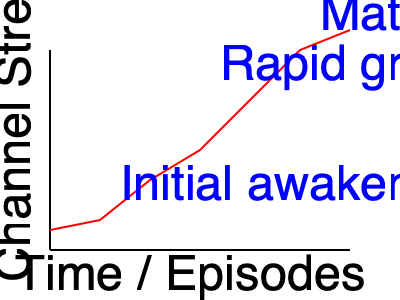Analyze the graph representing Naota's N.O. channel strength throughout FLCL. How does this visualization symbolize Naota's coming-of-age journey, and what specific events in the series might correspond to the marked points of change? 1. Initial state: The graph begins with a relatively flat line, representing Naota's dormant N.O. channel at the start of the series.

2. Awakening: The first significant change occurs early in the series, likely corresponding to Haruko's arrival and the first emergence of robots from Naota's head.

3. Gradual increase: The line shows a steady upward trend, symbolizing Naota's growing understanding of his abilities and the bizarre events around him.

4. Rapid growth: Midway through the series, there's a sharp increase in the graph. This could represent pivotal moments like Naota's interactions with Mamimi or confrontations with Medical Mechanica.

5. Peak: The graph reaches its highest point near the end, symbolizing Naota's full awakening and ability to control his N.O. channel.

6. Slight decline: The small dip at the very end might represent Naota's return to a new normalcy, but with retained growth and maturity.

7. Overall shape: The exponential curve mirrors the typical coming-of-age narrative, with accelerated growth and self-discovery towards the end.

This graph symbolizes Naota's journey from a passive, confused child to an active, self-aware young adult, mirroring FLCL's themes of adolescence and growth.
Answer: The graph symbolizes Naota's coming-of-age journey through exponential growth of his N.O. channel strength, reflecting key events like Haruko's arrival, confrontations with Medical Mechanica, and his final self-realization. 